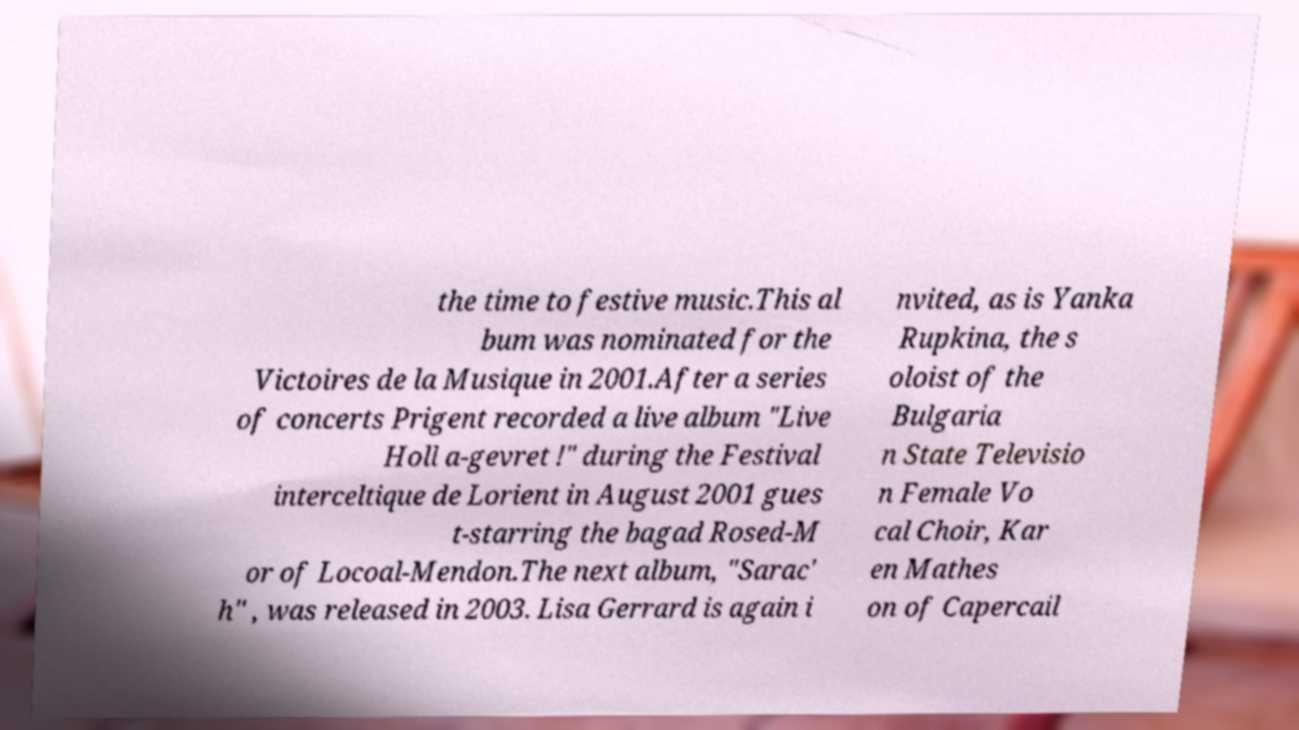Can you accurately transcribe the text from the provided image for me? the time to festive music.This al bum was nominated for the Victoires de la Musique in 2001.After a series of concerts Prigent recorded a live album "Live Holl a-gevret !" during the Festival interceltique de Lorient in August 2001 gues t-starring the bagad Rosed-M or of Locoal-Mendon.The next album, "Sarac' h" , was released in 2003. Lisa Gerrard is again i nvited, as is Yanka Rupkina, the s oloist of the Bulgaria n State Televisio n Female Vo cal Choir, Kar en Mathes on of Capercail 